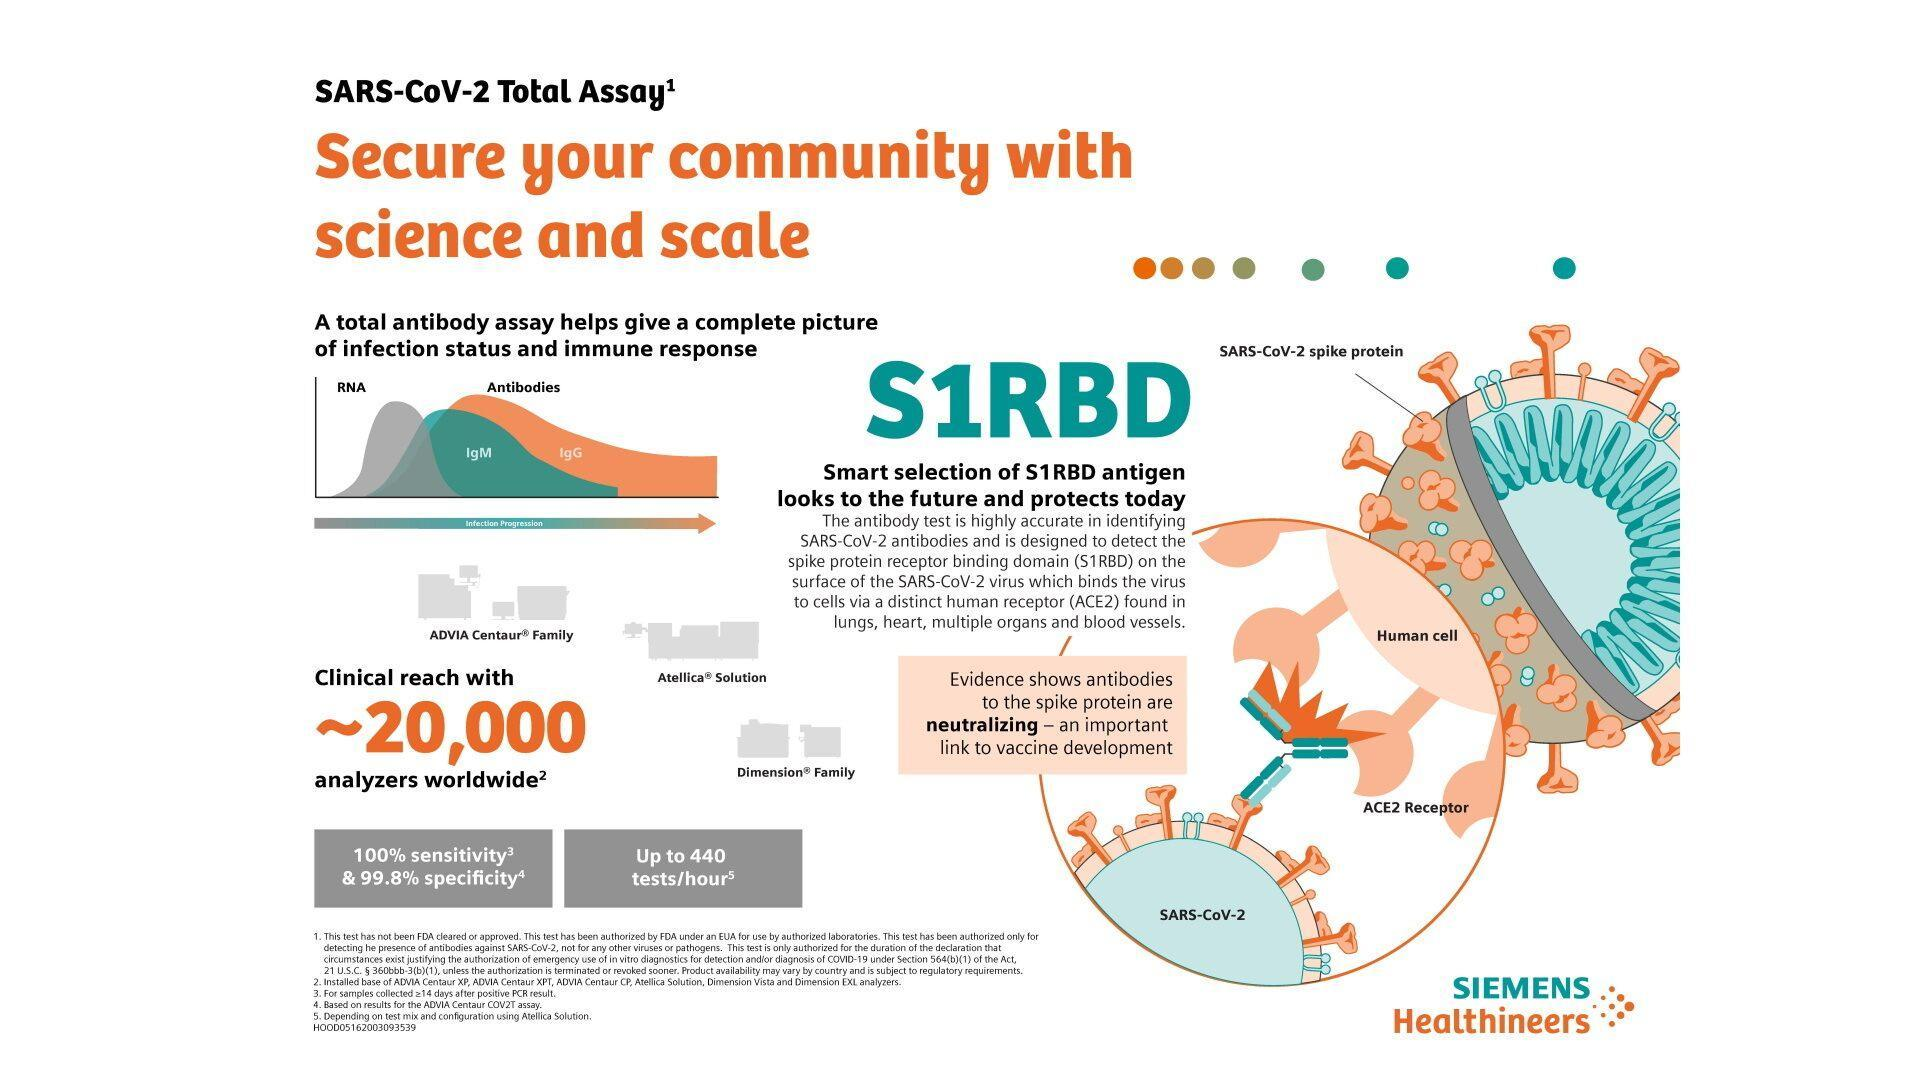What are the antibodies listed in the infographic?
Answer the question with a short phrase. IgM, IgG What is the color code given to IgM antibody- red, green, yellow, orange? green What is the color code given to IgG antibody- green, grey, yellow, orange? orange Which are the main organs listed where ACE2 receptor is seen? lungs, heart What is the no of antibody tests in an hour COV2T assay? Up to 440 